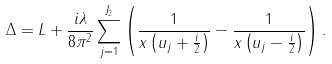Convert formula to latex. <formula><loc_0><loc_0><loc_500><loc_500>\Delta = L + \frac { i \lambda } { 8 \pi ^ { 2 } } \sum _ { j = 1 } ^ { J _ { 2 } } \left ( \frac { 1 } { x \left ( u _ { j } + \frac { i } { 2 } \right ) } - \frac { 1 } { x \left ( u _ { j } - \frac { i } { 2 } \right ) } \right ) .</formula> 